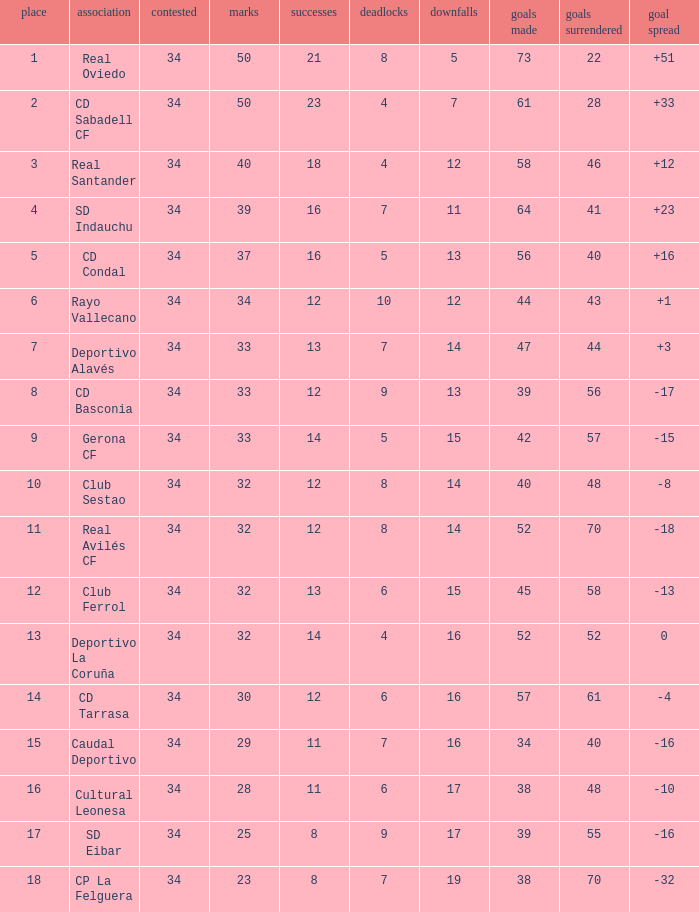Which Losses have a Goal Difference of -16, and less than 8 wins? None. 